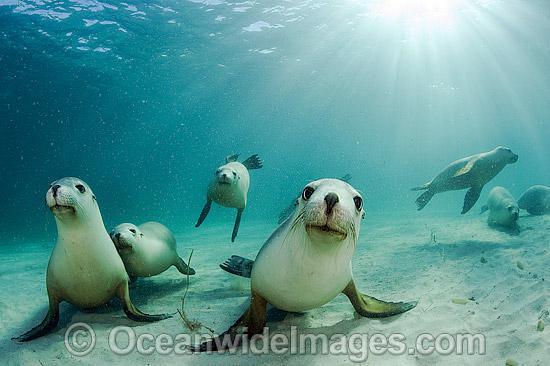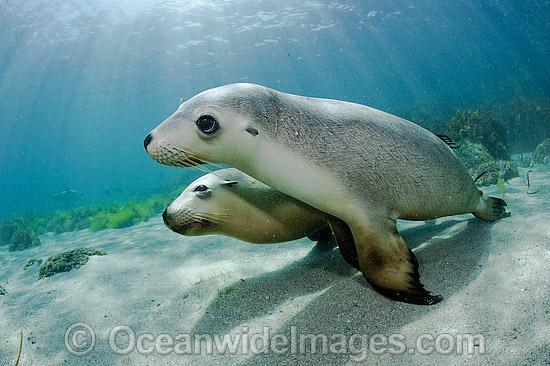The first image is the image on the left, the second image is the image on the right. Evaluate the accuracy of this statement regarding the images: "A single seal is face to face with the camera in the image on the left.". Is it true? Answer yes or no. No. The first image is the image on the left, the second image is the image on the right. Examine the images to the left and right. Is the description "In one image there are at least six sea lions." accurate? Answer yes or no. Yes. The first image is the image on the left, the second image is the image on the right. For the images shown, is this caption "An image shows a camera-facing seal with at least four other seals underwater in the background." true? Answer yes or no. Yes. The first image is the image on the left, the second image is the image on the right. Given the left and right images, does the statement "In the left image, there's only one seal and it's looking directly at the camera." hold true? Answer yes or no. No. 